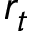Convert formula to latex. <formula><loc_0><loc_0><loc_500><loc_500>r _ { t }</formula> 